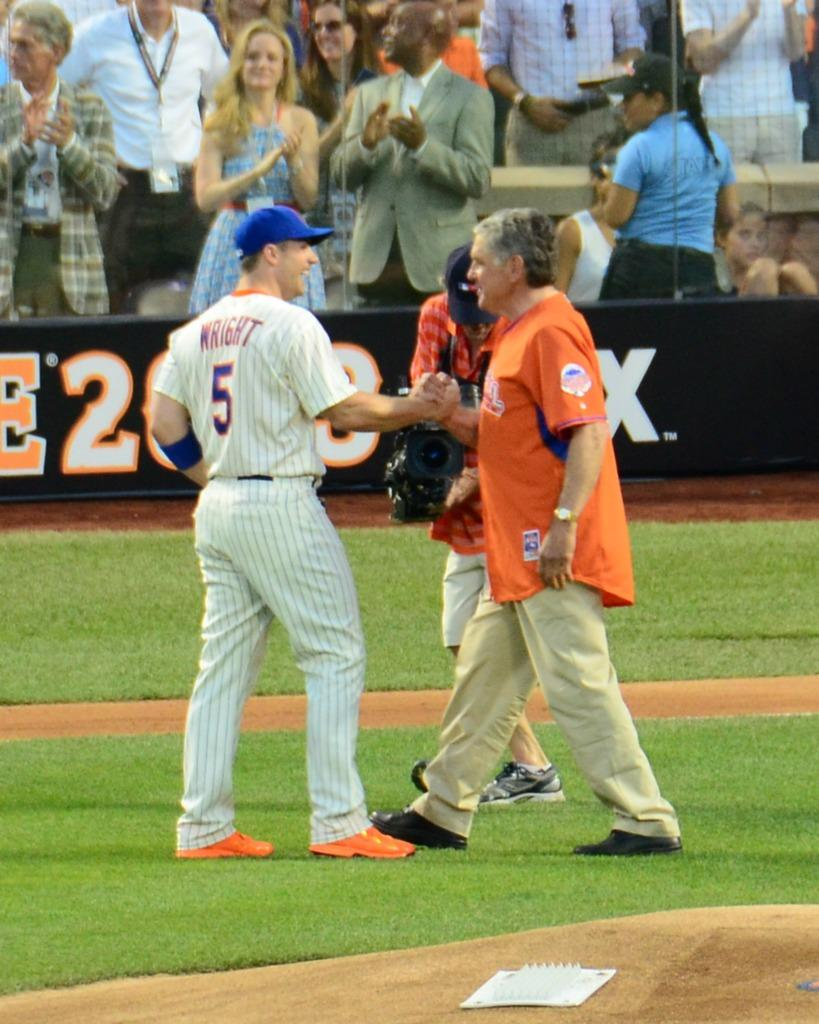<image>
Write a terse but informative summary of the picture. a player with the name wright on their jersey 